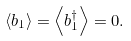Convert formula to latex. <formula><loc_0><loc_0><loc_500><loc_500>\left \langle b _ { 1 } \right \rangle = \left \langle b _ { 1 } ^ { \dagger } \right \rangle = 0 .</formula> 